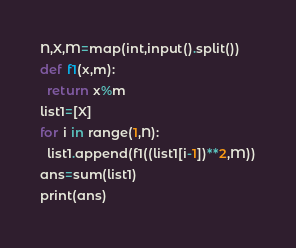Convert code to text. <code><loc_0><loc_0><loc_500><loc_500><_Python_>N,X,M=map(int,input().split())
def f1(x,m):
  return x%m
list1=[X]
for i in range(1,N):
  list1.append(f1((list1[i-1])**2,M))
ans=sum(list1)
print(ans)</code> 